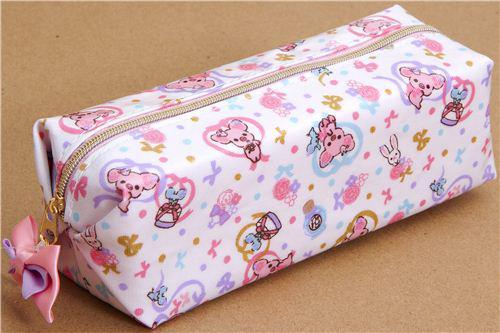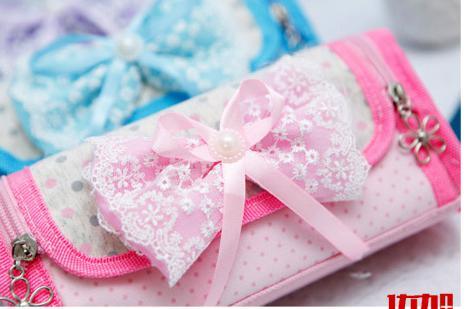The first image is the image on the left, the second image is the image on the right. Assess this claim about the two images: "The left image features a case with one zipper across the top, with a charm attached to the zipper pull, and an all-over print depicting cute animals, and the right image shows a mostly pink case closest to the camera.". Correct or not? Answer yes or no. Yes. The first image is the image on the left, the second image is the image on the right. Evaluate the accuracy of this statement regarding the images: "The bag on the left is a rectangular cuboid.". Is it true? Answer yes or no. Yes. 